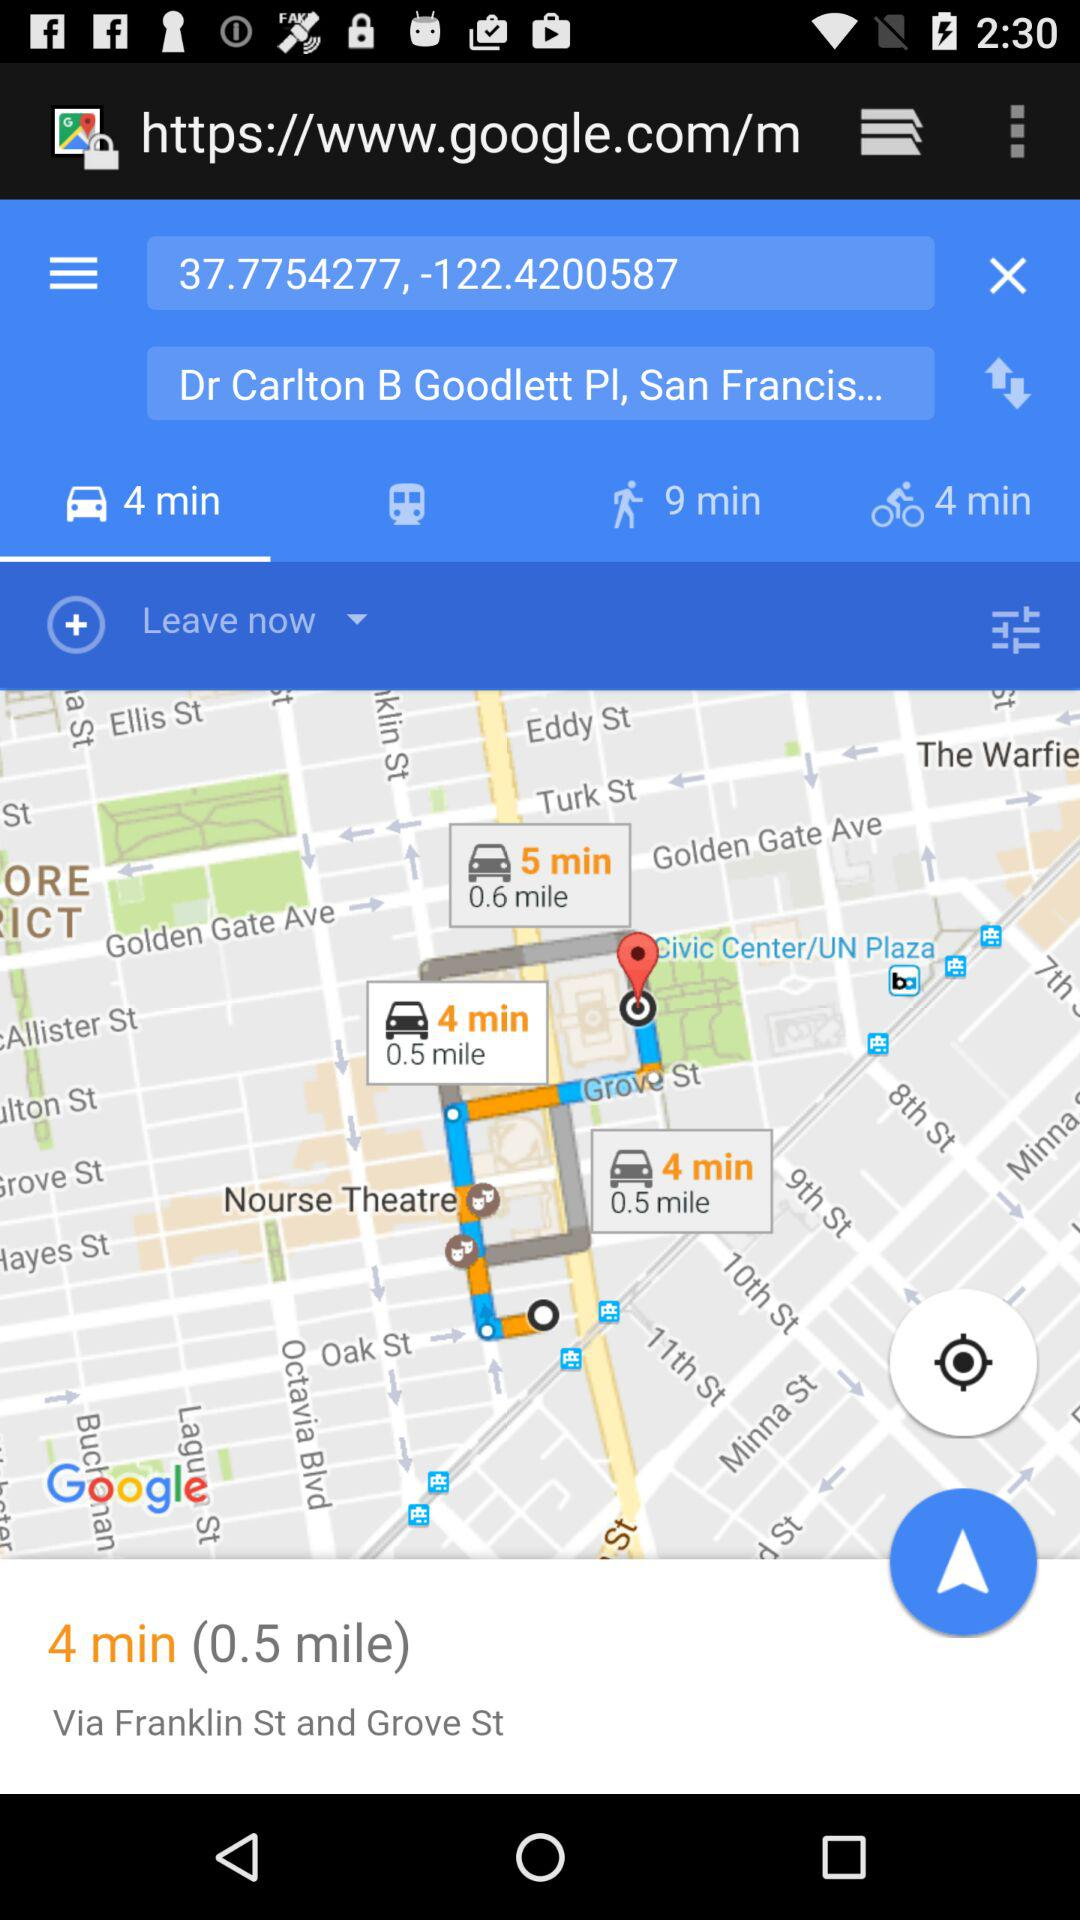What are the street names to reach "Dr Carlton B Goodlett Pl, San Francis..."? The street names are "Franklin St and Grove St". 